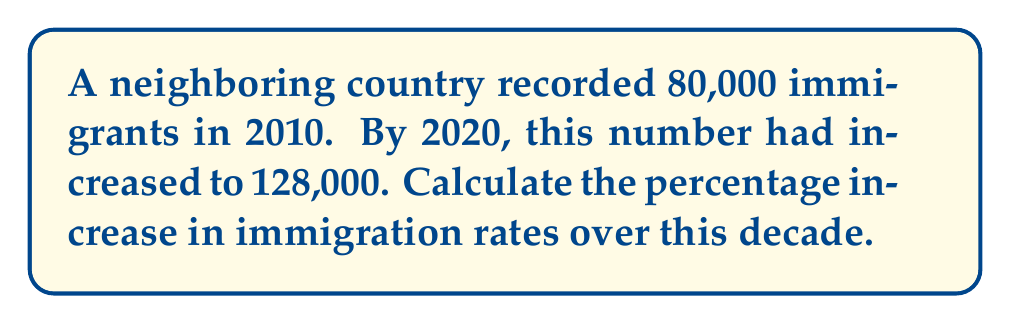What is the answer to this math problem? To calculate the percentage increase in immigration rates, we'll follow these steps:

1. Calculate the difference in immigration numbers:
   $\text{Difference} = 128,000 - 80,000 = 48,000$

2. Divide the difference by the original number:
   $\frac{\text{Difference}}{\text{Original Number}} = \frac{48,000}{80,000} = 0.6$

3. Convert the result to a percentage by multiplying by 100:
   $0.6 \times 100 = 60\%$

Therefore, the percentage increase in immigration rates over the decade is 60%.

This calculation can be expressed in a single formula:

$$\text{Percentage Increase} = \frac{\text{New Value} - \text{Original Value}}{\text{Original Value}} \times 100\%$$

$$= \frac{128,000 - 80,000}{80,000} \times 100\% = 60\%$$
Answer: 60% 